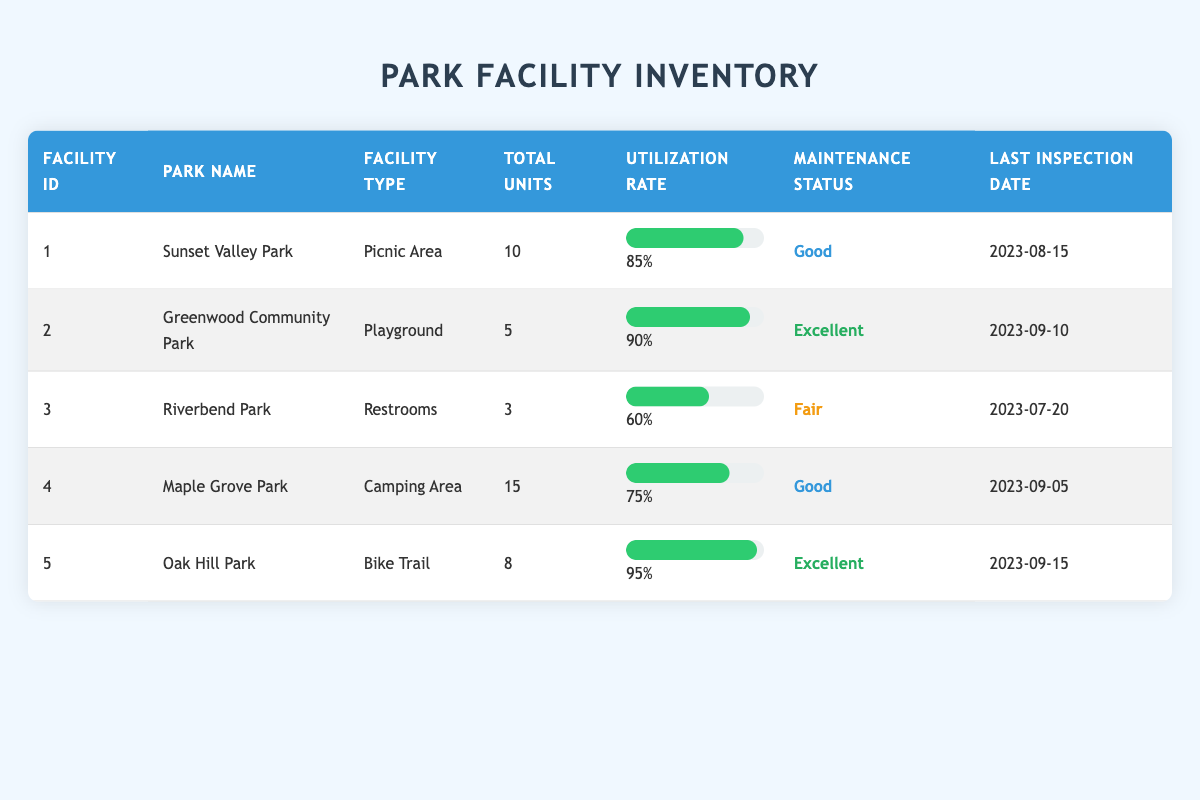What is the total number of facilities listed in the inventory? The table shows five facilities (Sunset Valley Park, Greenwood Community Park, Riverbend Park, Maple Grove Park, and Oak Hill Park). Thus, the total count is 5.
Answer: 5 What is the utilization rate of the Bike Trail in Oak Hill Park? The table indicates that the utilization rate for the Bike Trail in Oak Hill Park is 95%.
Answer: 95% Which park has the lowest utilization rate and what is that rate? By examining the table, Riverbend Park has the lowest utilization rate at 60%.
Answer: 60% What is the average utilization rate of all the parks? The utilization rates are 85, 90, 60, 75, and 95. The sum is 85 + 90 + 60 + 75 + 95 = 405. There are 5 parks, so the average is 405 / 5 = 81.
Answer: 81 Is there any facility in 'Fair' maintenance status? Yes, Riverbend Park has a 'Fair' maintenance status for its Restrooms.
Answer: Yes Which facility has the highest total units and what is it? The Camping Area in Maple Grove Park has the highest number of total units at 15.
Answer: 15 How many parks have a utilization rate of 80% or higher? The parks with utilization rates of 80% or higher are Sunset Valley Park (85%), Greenwood Community Park (90%), Oak Hill Park (95%), and Maple Grove Park (75%). Therefore, there are 3 parks above 80%.
Answer: 3 What is the maintenance status of the Playground in Greenwood Community Park? The table shows that the Playground in Greenwood Community Park is in 'Excellent' maintenance status.
Answer: Excellent Which park facility has the latest last inspection date? By checking the last inspection dates, Oak Hill Park’s last inspection date is September 15, 2023, which is the latest.
Answer: Oak Hill Park 